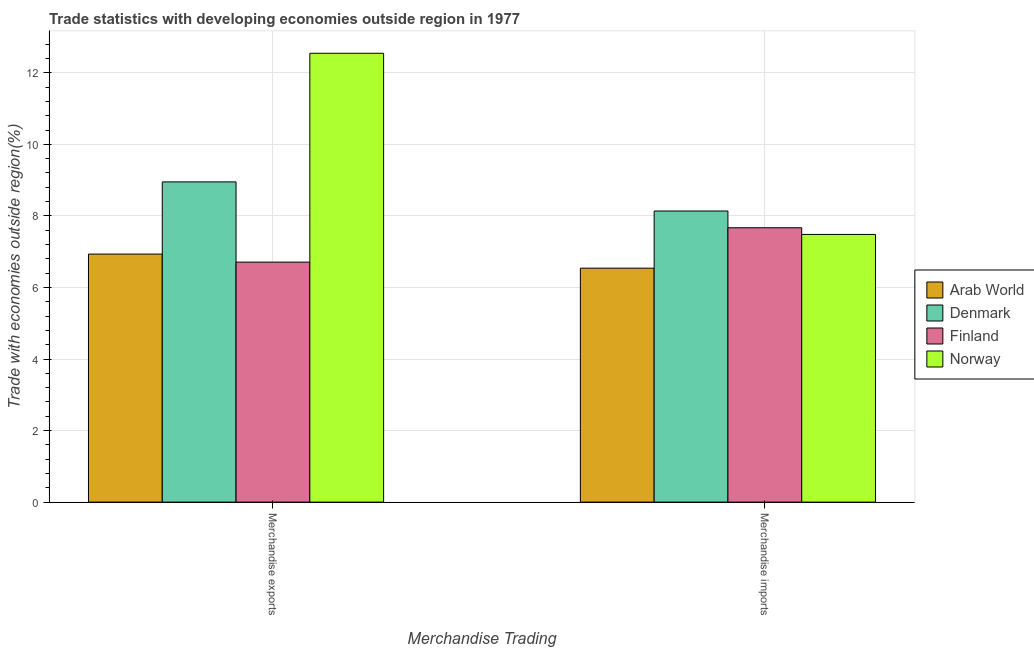How many different coloured bars are there?
Offer a terse response. 4. Are the number of bars per tick equal to the number of legend labels?
Offer a very short reply. Yes. Are the number of bars on each tick of the X-axis equal?
Give a very brief answer. Yes. How many bars are there on the 1st tick from the right?
Provide a succinct answer. 4. What is the label of the 2nd group of bars from the left?
Provide a succinct answer. Merchandise imports. What is the merchandise imports in Arab World?
Give a very brief answer. 6.54. Across all countries, what is the maximum merchandise imports?
Ensure brevity in your answer.  8.14. Across all countries, what is the minimum merchandise exports?
Ensure brevity in your answer.  6.71. In which country was the merchandise imports maximum?
Offer a very short reply. Denmark. What is the total merchandise exports in the graph?
Your answer should be very brief. 35.14. What is the difference between the merchandise imports in Arab World and that in Finland?
Your answer should be very brief. -1.13. What is the difference between the merchandise exports in Finland and the merchandise imports in Arab World?
Your answer should be compact. 0.17. What is the average merchandise exports per country?
Ensure brevity in your answer.  8.79. What is the difference between the merchandise exports and merchandise imports in Arab World?
Your response must be concise. 0.39. What is the ratio of the merchandise imports in Arab World to that in Norway?
Your answer should be compact. 0.87. In how many countries, is the merchandise exports greater than the average merchandise exports taken over all countries?
Your answer should be compact. 2. What does the 1st bar from the left in Merchandise imports represents?
Your response must be concise. Arab World. How many bars are there?
Offer a terse response. 8. Are all the bars in the graph horizontal?
Provide a short and direct response. No. How many countries are there in the graph?
Offer a very short reply. 4. Does the graph contain grids?
Provide a short and direct response. Yes. How many legend labels are there?
Give a very brief answer. 4. How are the legend labels stacked?
Give a very brief answer. Vertical. What is the title of the graph?
Provide a short and direct response. Trade statistics with developing economies outside region in 1977. What is the label or title of the X-axis?
Keep it short and to the point. Merchandise Trading. What is the label or title of the Y-axis?
Offer a very short reply. Trade with economies outside region(%). What is the Trade with economies outside region(%) of Arab World in Merchandise exports?
Give a very brief answer. 6.93. What is the Trade with economies outside region(%) in Denmark in Merchandise exports?
Your answer should be compact. 8.95. What is the Trade with economies outside region(%) in Finland in Merchandise exports?
Make the answer very short. 6.71. What is the Trade with economies outside region(%) of Norway in Merchandise exports?
Provide a succinct answer. 12.55. What is the Trade with economies outside region(%) in Arab World in Merchandise imports?
Your response must be concise. 6.54. What is the Trade with economies outside region(%) in Denmark in Merchandise imports?
Keep it short and to the point. 8.14. What is the Trade with economies outside region(%) in Finland in Merchandise imports?
Offer a very short reply. 7.67. What is the Trade with economies outside region(%) of Norway in Merchandise imports?
Make the answer very short. 7.48. Across all Merchandise Trading, what is the maximum Trade with economies outside region(%) in Arab World?
Offer a terse response. 6.93. Across all Merchandise Trading, what is the maximum Trade with economies outside region(%) of Denmark?
Give a very brief answer. 8.95. Across all Merchandise Trading, what is the maximum Trade with economies outside region(%) in Finland?
Offer a very short reply. 7.67. Across all Merchandise Trading, what is the maximum Trade with economies outside region(%) in Norway?
Give a very brief answer. 12.55. Across all Merchandise Trading, what is the minimum Trade with economies outside region(%) in Arab World?
Your answer should be compact. 6.54. Across all Merchandise Trading, what is the minimum Trade with economies outside region(%) of Denmark?
Your response must be concise. 8.14. Across all Merchandise Trading, what is the minimum Trade with economies outside region(%) of Finland?
Give a very brief answer. 6.71. Across all Merchandise Trading, what is the minimum Trade with economies outside region(%) in Norway?
Your response must be concise. 7.48. What is the total Trade with economies outside region(%) of Arab World in the graph?
Make the answer very short. 13.47. What is the total Trade with economies outside region(%) of Denmark in the graph?
Offer a very short reply. 17.09. What is the total Trade with economies outside region(%) in Finland in the graph?
Your answer should be compact. 14.38. What is the total Trade with economies outside region(%) of Norway in the graph?
Provide a short and direct response. 20.03. What is the difference between the Trade with economies outside region(%) in Arab World in Merchandise exports and that in Merchandise imports?
Provide a short and direct response. 0.39. What is the difference between the Trade with economies outside region(%) of Denmark in Merchandise exports and that in Merchandise imports?
Provide a succinct answer. 0.81. What is the difference between the Trade with economies outside region(%) in Finland in Merchandise exports and that in Merchandise imports?
Offer a very short reply. -0.96. What is the difference between the Trade with economies outside region(%) of Norway in Merchandise exports and that in Merchandise imports?
Provide a short and direct response. 5.06. What is the difference between the Trade with economies outside region(%) in Arab World in Merchandise exports and the Trade with economies outside region(%) in Denmark in Merchandise imports?
Offer a very short reply. -1.2. What is the difference between the Trade with economies outside region(%) of Arab World in Merchandise exports and the Trade with economies outside region(%) of Finland in Merchandise imports?
Give a very brief answer. -0.74. What is the difference between the Trade with economies outside region(%) in Arab World in Merchandise exports and the Trade with economies outside region(%) in Norway in Merchandise imports?
Offer a very short reply. -0.55. What is the difference between the Trade with economies outside region(%) of Denmark in Merchandise exports and the Trade with economies outside region(%) of Finland in Merchandise imports?
Give a very brief answer. 1.28. What is the difference between the Trade with economies outside region(%) in Denmark in Merchandise exports and the Trade with economies outside region(%) in Norway in Merchandise imports?
Your answer should be compact. 1.47. What is the difference between the Trade with economies outside region(%) in Finland in Merchandise exports and the Trade with economies outside region(%) in Norway in Merchandise imports?
Keep it short and to the point. -0.77. What is the average Trade with economies outside region(%) in Arab World per Merchandise Trading?
Ensure brevity in your answer.  6.74. What is the average Trade with economies outside region(%) in Denmark per Merchandise Trading?
Provide a short and direct response. 8.54. What is the average Trade with economies outside region(%) of Finland per Merchandise Trading?
Provide a short and direct response. 7.19. What is the average Trade with economies outside region(%) of Norway per Merchandise Trading?
Provide a short and direct response. 10.01. What is the difference between the Trade with economies outside region(%) in Arab World and Trade with economies outside region(%) in Denmark in Merchandise exports?
Offer a terse response. -2.02. What is the difference between the Trade with economies outside region(%) of Arab World and Trade with economies outside region(%) of Finland in Merchandise exports?
Offer a very short reply. 0.22. What is the difference between the Trade with economies outside region(%) of Arab World and Trade with economies outside region(%) of Norway in Merchandise exports?
Keep it short and to the point. -5.61. What is the difference between the Trade with economies outside region(%) of Denmark and Trade with economies outside region(%) of Finland in Merchandise exports?
Keep it short and to the point. 2.24. What is the difference between the Trade with economies outside region(%) of Denmark and Trade with economies outside region(%) of Norway in Merchandise exports?
Your response must be concise. -3.6. What is the difference between the Trade with economies outside region(%) of Finland and Trade with economies outside region(%) of Norway in Merchandise exports?
Give a very brief answer. -5.84. What is the difference between the Trade with economies outside region(%) in Arab World and Trade with economies outside region(%) in Denmark in Merchandise imports?
Ensure brevity in your answer.  -1.6. What is the difference between the Trade with economies outside region(%) of Arab World and Trade with economies outside region(%) of Finland in Merchandise imports?
Make the answer very short. -1.13. What is the difference between the Trade with economies outside region(%) of Arab World and Trade with economies outside region(%) of Norway in Merchandise imports?
Provide a short and direct response. -0.94. What is the difference between the Trade with economies outside region(%) of Denmark and Trade with economies outside region(%) of Finland in Merchandise imports?
Give a very brief answer. 0.47. What is the difference between the Trade with economies outside region(%) of Denmark and Trade with economies outside region(%) of Norway in Merchandise imports?
Offer a terse response. 0.65. What is the difference between the Trade with economies outside region(%) in Finland and Trade with economies outside region(%) in Norway in Merchandise imports?
Provide a short and direct response. 0.19. What is the ratio of the Trade with economies outside region(%) of Arab World in Merchandise exports to that in Merchandise imports?
Keep it short and to the point. 1.06. What is the ratio of the Trade with economies outside region(%) in Finland in Merchandise exports to that in Merchandise imports?
Your answer should be very brief. 0.87. What is the ratio of the Trade with economies outside region(%) of Norway in Merchandise exports to that in Merchandise imports?
Offer a terse response. 1.68. What is the difference between the highest and the second highest Trade with economies outside region(%) of Arab World?
Your response must be concise. 0.39. What is the difference between the highest and the second highest Trade with economies outside region(%) in Denmark?
Ensure brevity in your answer.  0.81. What is the difference between the highest and the second highest Trade with economies outside region(%) in Finland?
Make the answer very short. 0.96. What is the difference between the highest and the second highest Trade with economies outside region(%) of Norway?
Provide a short and direct response. 5.06. What is the difference between the highest and the lowest Trade with economies outside region(%) in Arab World?
Keep it short and to the point. 0.39. What is the difference between the highest and the lowest Trade with economies outside region(%) of Denmark?
Your answer should be very brief. 0.81. What is the difference between the highest and the lowest Trade with economies outside region(%) in Finland?
Provide a short and direct response. 0.96. What is the difference between the highest and the lowest Trade with economies outside region(%) of Norway?
Ensure brevity in your answer.  5.06. 